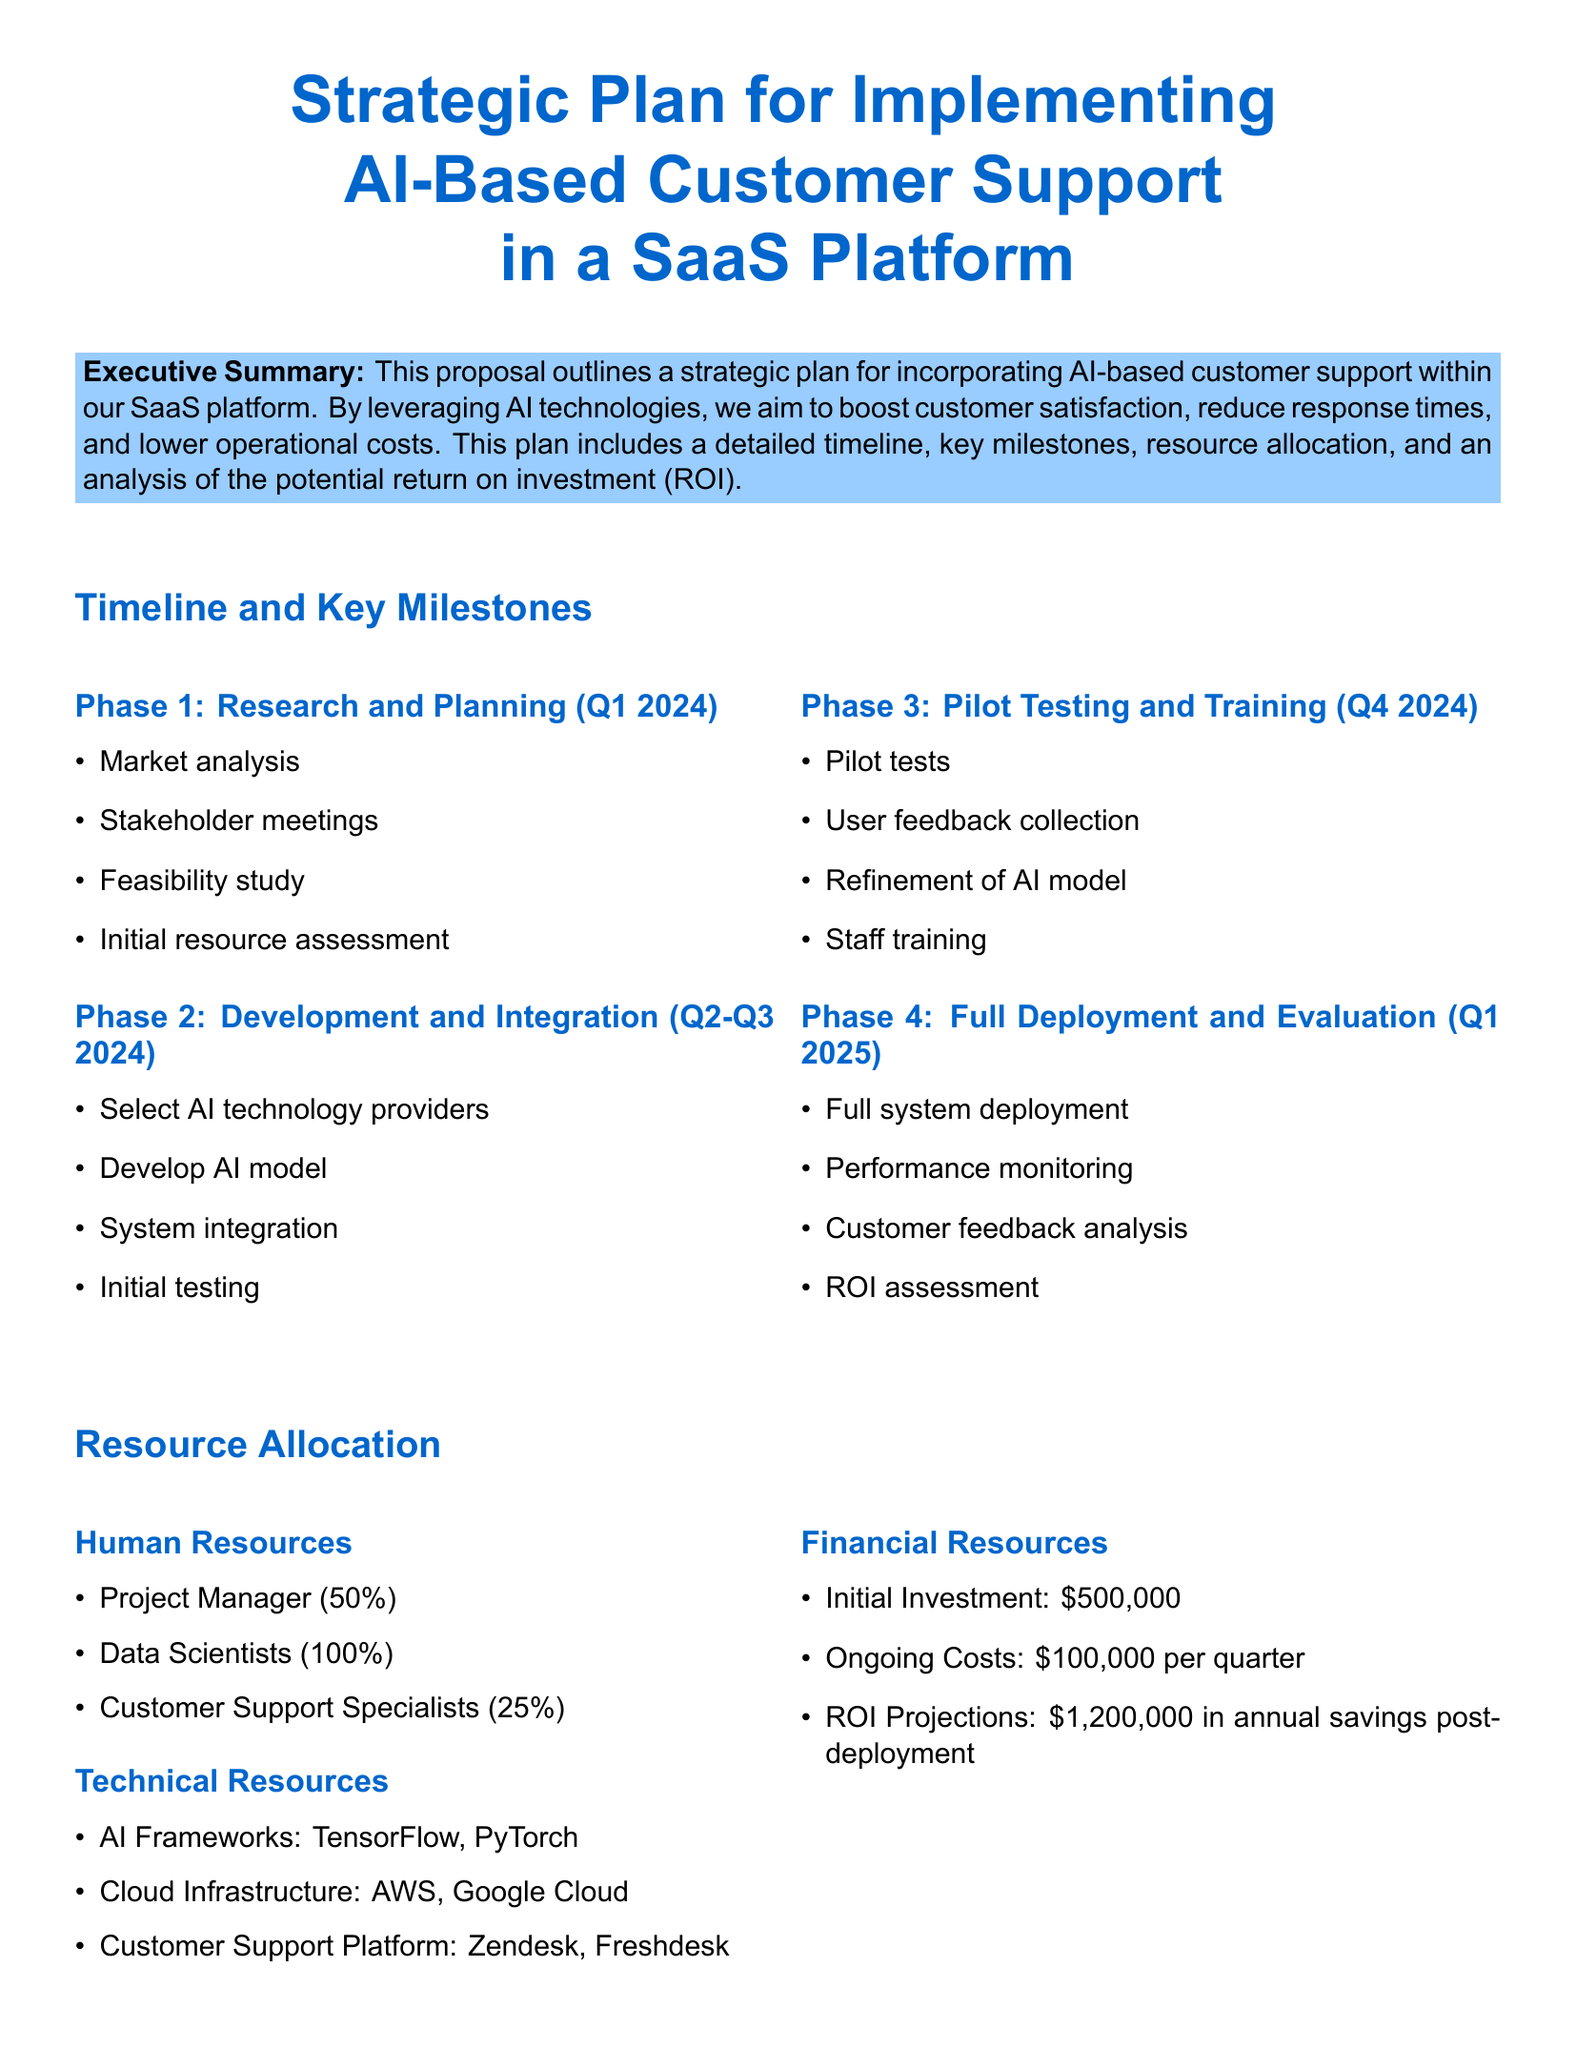What is the initial investment? The initial investment is outlined in the resource allocation section of the document, which specifies financial resources.
Answer: $500,000 What are the two AI frameworks mentioned? The technical resources section lists the AI frameworks that will be utilized during the project.
Answer: TensorFlow, PyTorch How long will the pilot testing phase last? The timeline details indicate that pilot testing will occur in the fourth quarter of 2024.
Answer: Q4 2024 What role has a 50% allocation of resources? The resource allocation section describes the human resources and their respective allocations for this project.
Answer: Project Manager What is the projected ROI in annual savings post-deployment? The potential ROI section provides projections for savings following the full deployment of the AI-based support.
Answer: $1,200,000 Which cloud infrastructures are mentioned? The technical resources section specifies the cloud infrastructures that will support the AI project.
Answer: AWS, Google Cloud What is the main goal of implementing AI-based customer support? The executive summary outlines the goals of improving customer satisfaction, reducing response times, and lowering costs.
Answer: Boost customer satisfaction In which phase will staff training take place? The timeline and key milestones section describes the phases and relevant activities, specifically mentioning training.
Answer: Phase 3 What is the ongoing cost per quarter? The financial resources part of the document indicates the ongoing costs associated with the project.
Answer: $100,000 per quarter 